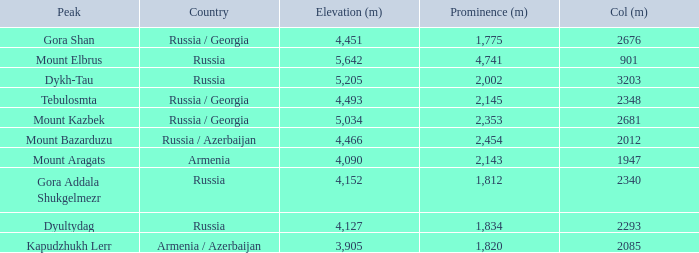Can you give me this table as a dict? {'header': ['Peak', 'Country', 'Elevation (m)', 'Prominence (m)', 'Col (m)'], 'rows': [['Gora Shan', 'Russia / Georgia', '4,451', '1,775', '2676'], ['Mount Elbrus', 'Russia', '5,642', '4,741', '901'], ['Dykh-Tau', 'Russia', '5,205', '2,002', '3203'], ['Tebulosmta', 'Russia / Georgia', '4,493', '2,145', '2348'], ['Mount Kazbek', 'Russia / Georgia', '5,034', '2,353', '2681'], ['Mount Bazarduzu', 'Russia / Azerbaijan', '4,466', '2,454', '2012'], ['Mount Aragats', 'Armenia', '4,090', '2,143', '1947'], ['Gora Addala Shukgelmezr', 'Russia', '4,152', '1,812', '2340'], ['Dyultydag', 'Russia', '4,127', '1,834', '2293'], ['Kapudzhukh Lerr', 'Armenia / Azerbaijan', '3,905', '1,820', '2085']]} What is the Col (m) of Peak Mount Aragats with an Elevation (m) larger than 3,905 and Prominence smaller than 2,143? None. 